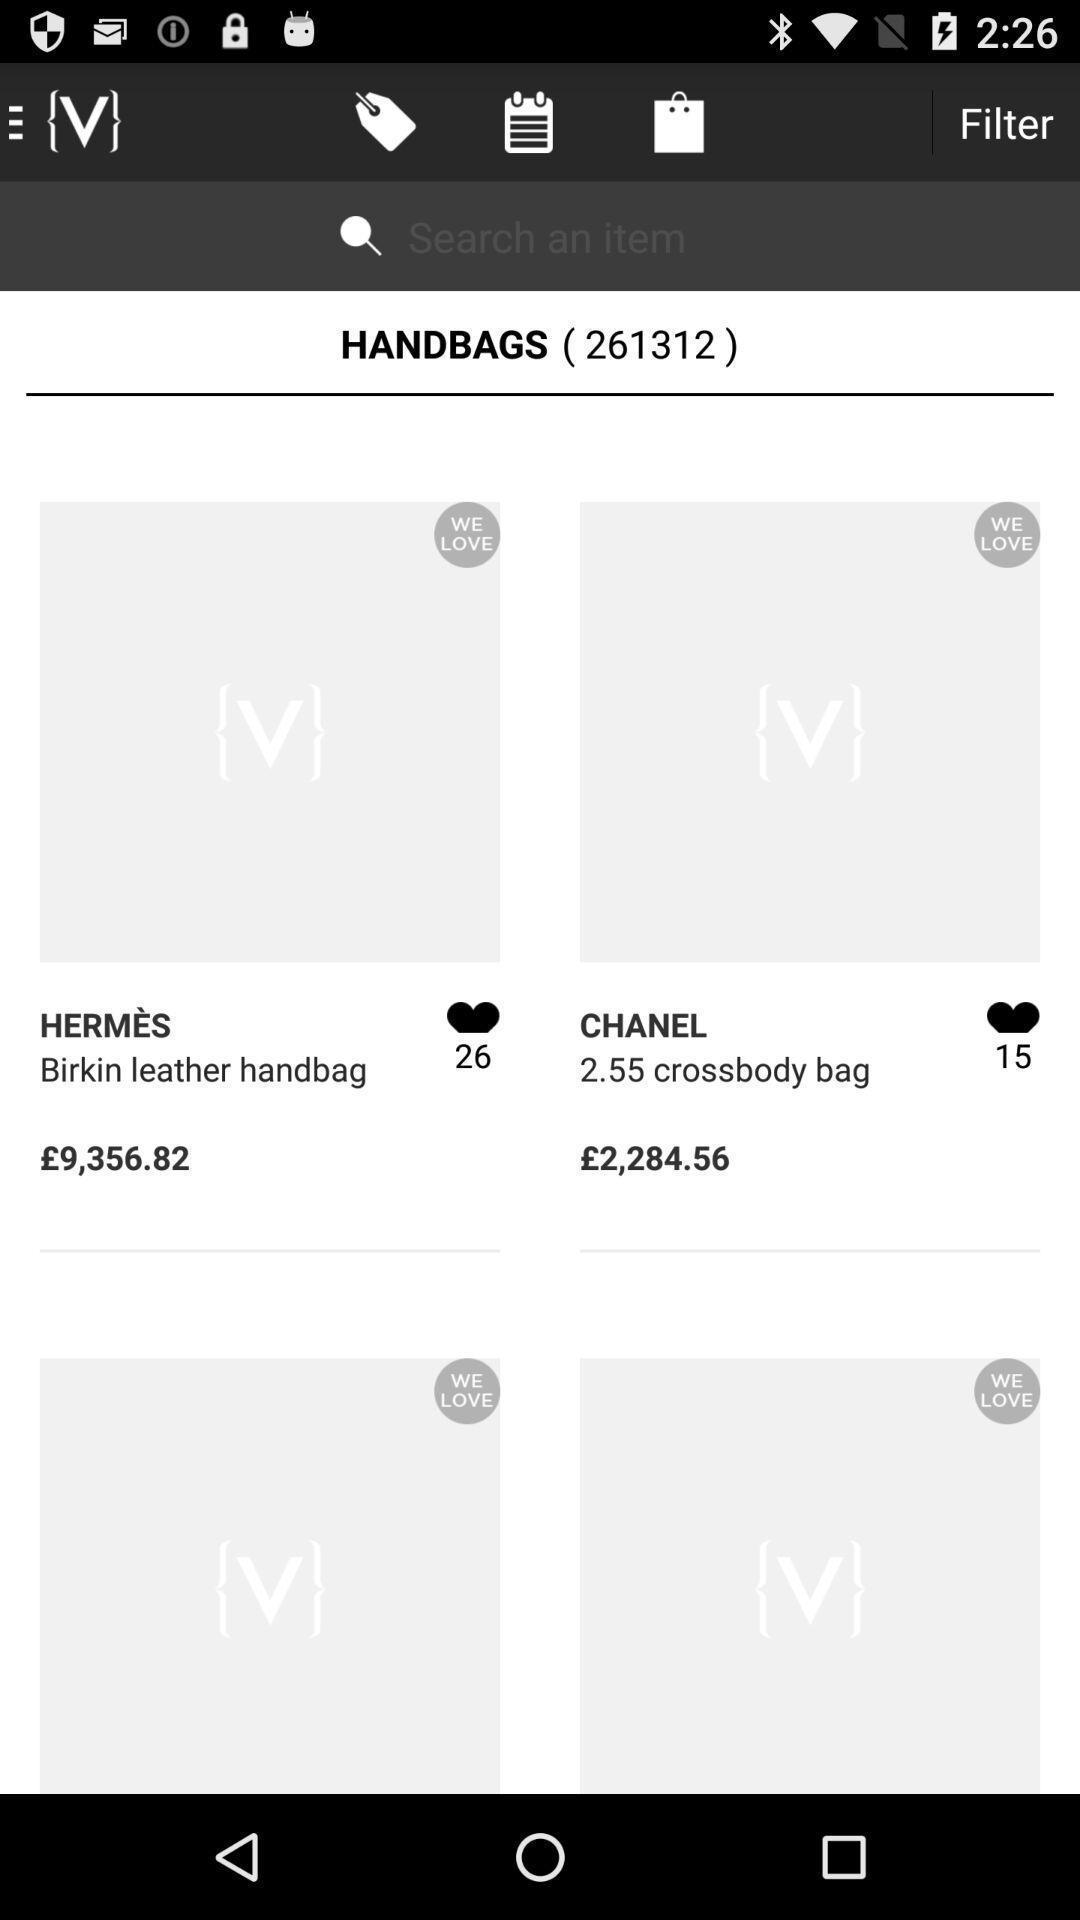Give me a narrative description of this picture. Page shows the handbags types and price on shopping app. 